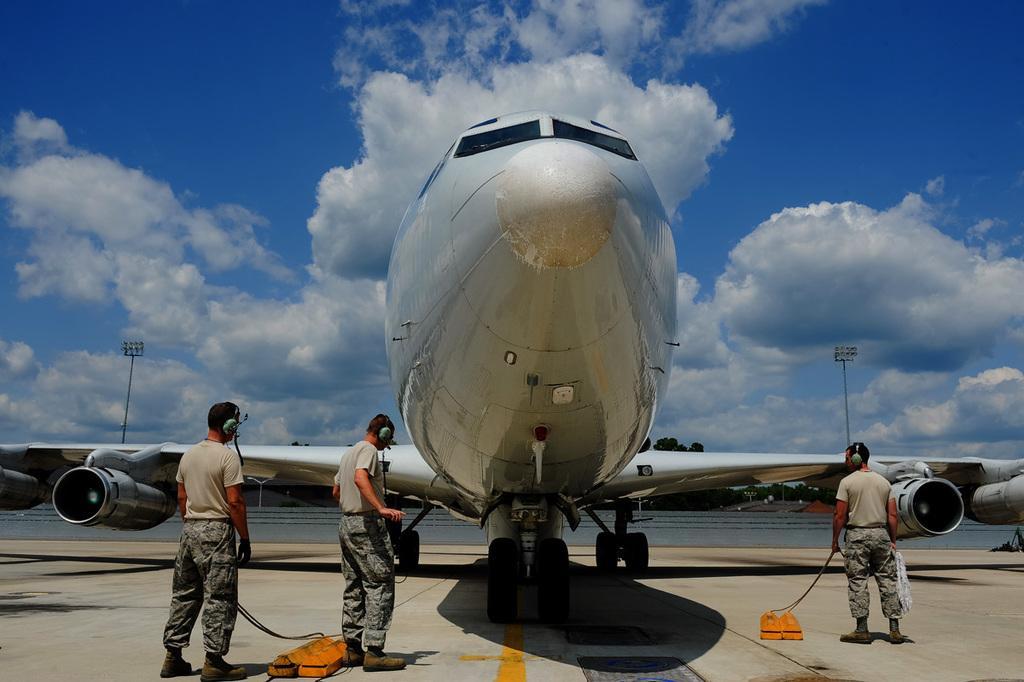How would you summarize this image in a sentence or two? There are two persons standing on the left side is wearing headphones and the person standing on the right side of this image is also wearing headphone and holding an object. There is an aeroplane in the middle of this image, and there is a cloudy sky in the background. 